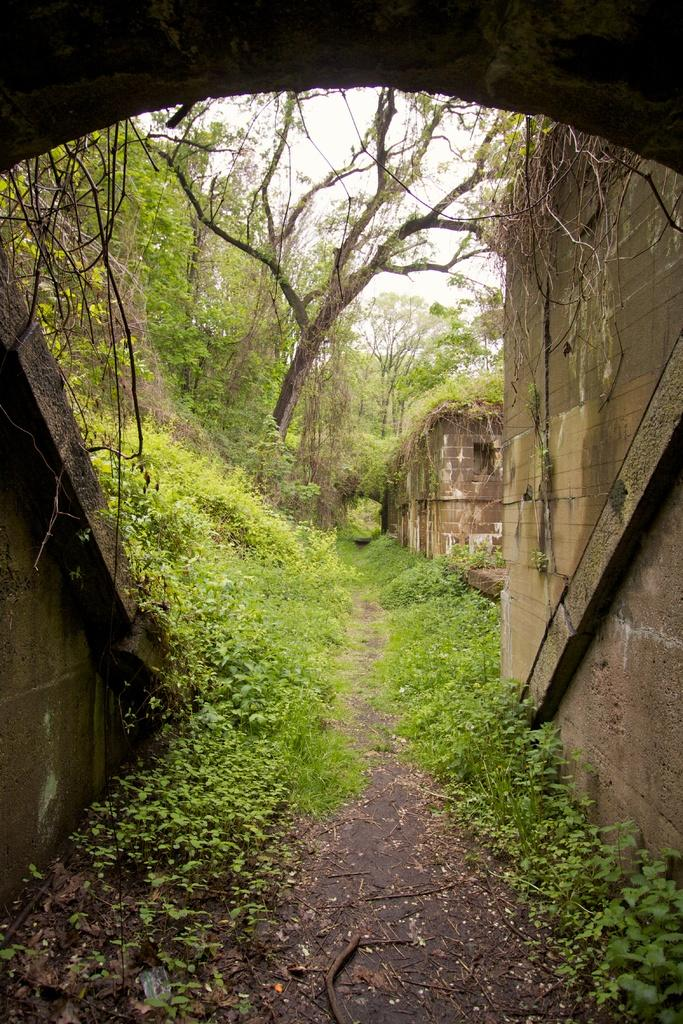What is located at the bottom of the picture? There is a road at the bottom of the picture. What can be found near the road? Herbs are present near the road. What is visible in the background of the image? There are many trees and a building in the background of the image. We start by identifying the main elements in the image, such as the road at the bottom, herbs near the road, and the presence of trees and a building in the background. We then formulate questions that focus on these elements, ensuring that each question can be answered definitively with the information given. We avoid yes/no questions and ensure that the language is simple and clear. Absurd Question/Answer: What type of yarn is being used to weave the trees in the background? There is no yarn present in the image, and the trees are not being woven. What type of engine is powering the trees in the background? There is no engine present in the image, and the trees are not being powered. 